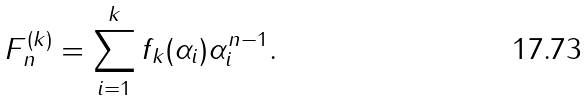Convert formula to latex. <formula><loc_0><loc_0><loc_500><loc_500>F _ { n } ^ { ( k ) } = \sum _ { i = 1 } ^ { k } f _ { k } ( \alpha _ { i } ) \alpha _ { i } ^ { n - 1 } .</formula> 